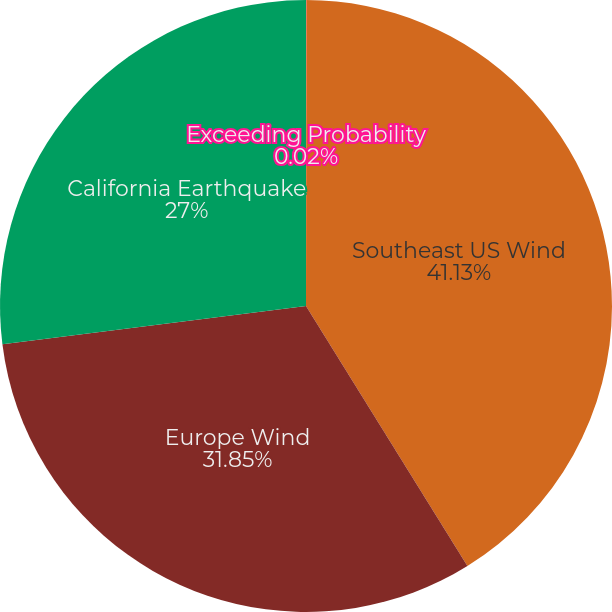Convert chart to OTSL. <chart><loc_0><loc_0><loc_500><loc_500><pie_chart><fcel>Exceeding Probability<fcel>Southeast US Wind<fcel>Europe Wind<fcel>California Earthquake<nl><fcel>0.02%<fcel>41.14%<fcel>31.85%<fcel>27.0%<nl></chart> 